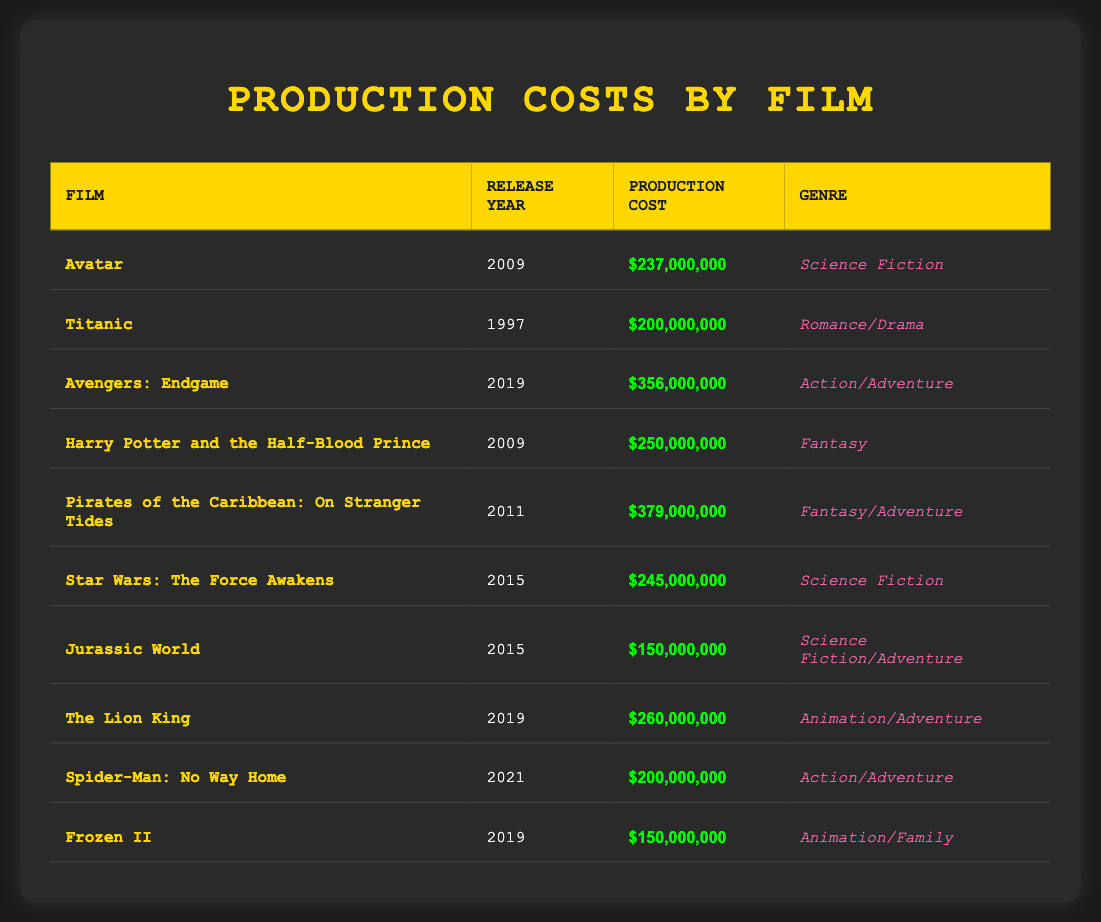What is the production cost of "Avatar"? The table directly lists the production cost for "Avatar" as $237,000,000.
Answer: $237,000,000 Which film has the highest production cost? By comparing all the production costs in the table, "Pirates of the Caribbean: On Stranger Tides" has the highest at $379,000,000.
Answer: $379,000,000 What is the average production cost of films released in 2019? The production costs for films released in 2019 are $356,000,000 (Avengers: Endgame), $260,000,000 (The Lion King), and $150,000,000 (Frozen II). Adding these values gives $766,000,000. There are three films, so the average is $766,000,000 divided by 3, which equals approximately $255,333,333.
Answer: $255,333,333 Is "Jurassic World" released after "Titanic"? "Jurassic World" was released in 2015, while "Titanic" was released in 1997, which confirms that "Jurassic World" is indeed released after "Titanic".
Answer: Yes How much more did "Avengers: Endgame" cost to produce compared to "Spider-Man: No Way Home"? The production cost of "Avengers: Endgame" is $356,000,000 and "Spider-Man: No Way Home" is $200,000,000. The difference is $356,000,000 minus $200,000,000, which equals $156,000,000.
Answer: $156,000,000 Are there any films in the table that have a production cost below $150,000,000? Checking the production costs listed, the lowest cost is for "Jurassic World" at $150,000,000, meaning there are no films with production costs below $150,000,000.
Answer: No What is the total production cost of films released in 2009? The films released in 2009 are "Avatar" at $237,000,000 and "Harry Potter and the Half-Blood Prince" at $250,000,000. Adding these gives a total of $487,000,000 for films released in that year.
Answer: $487,000,000 Which genre has the most films listed in the table? To determine the most frequent genre, we note that "Action/Adventure" appears twice (Avengers: Endgame and Spider-Man: No Way Home), while "Science Fiction" also appears twice (Avatar and Star Wars: The Force Awakens). All other genres appear only once. Thus, there is a tie between these two genres for most films listed.
Answer: Tie between Action/Adventure and Science Fiction What film genre does "Frozen II" belong to? The table explicitly states that "Frozen II" falls under the genre "Animation/Family."
Answer: Animation/Family 